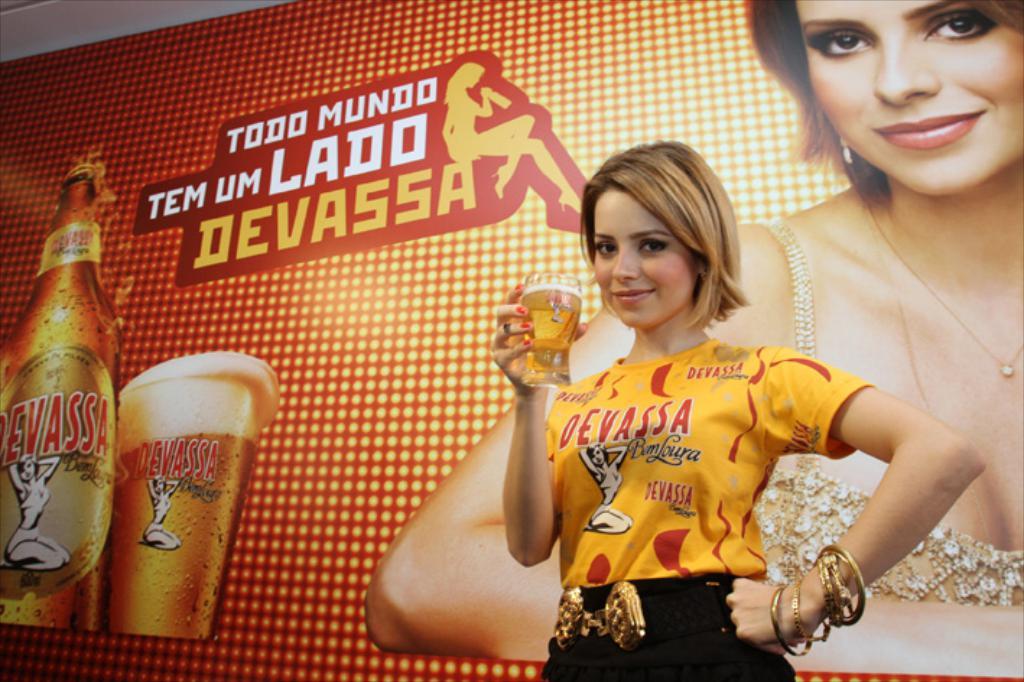What is the beer called?
Offer a very short reply. Devassa. 